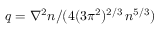Convert formula to latex. <formula><loc_0><loc_0><loc_500><loc_500>q = \nabla ^ { 2 } n / ( 4 ( 3 \pi ^ { 2 } ) ^ { 2 / 3 } \, n ^ { 5 / 3 } )</formula> 